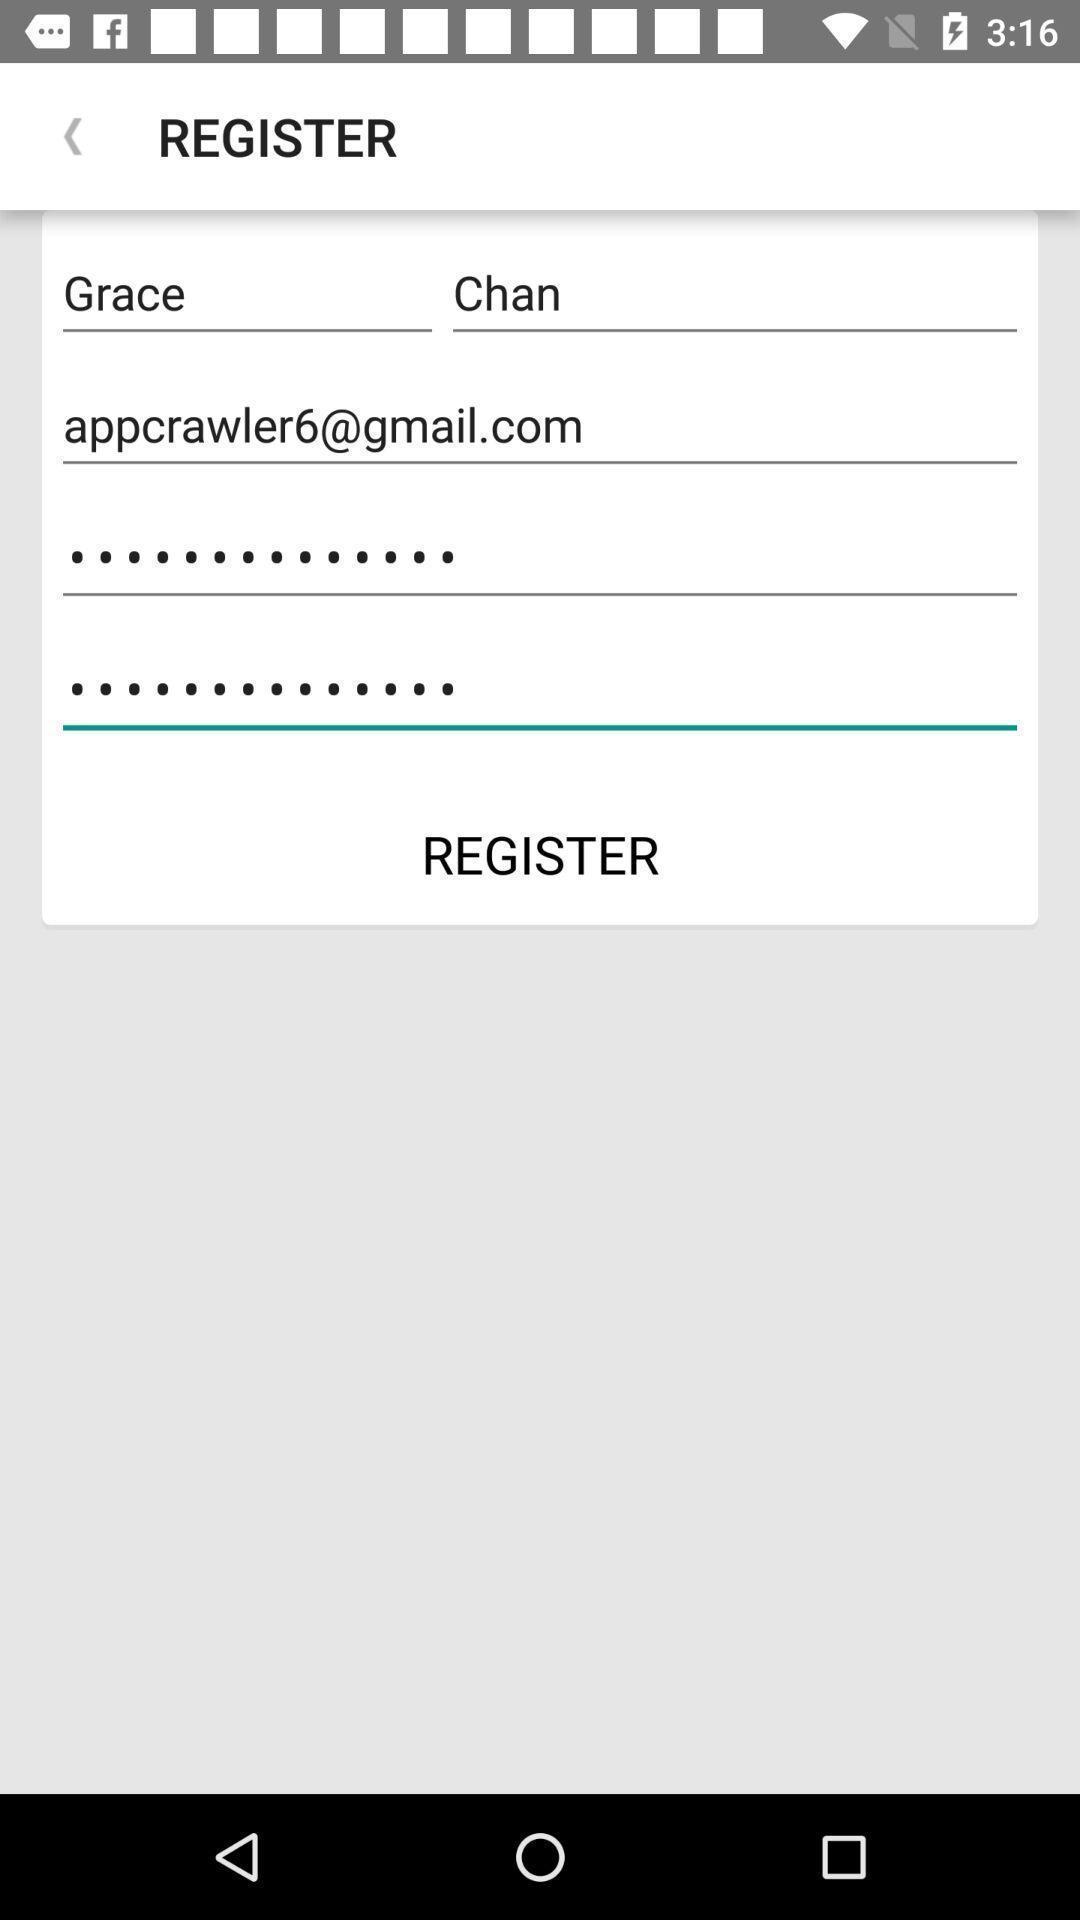Summarize the information in this screenshot. Screen shows register details. 